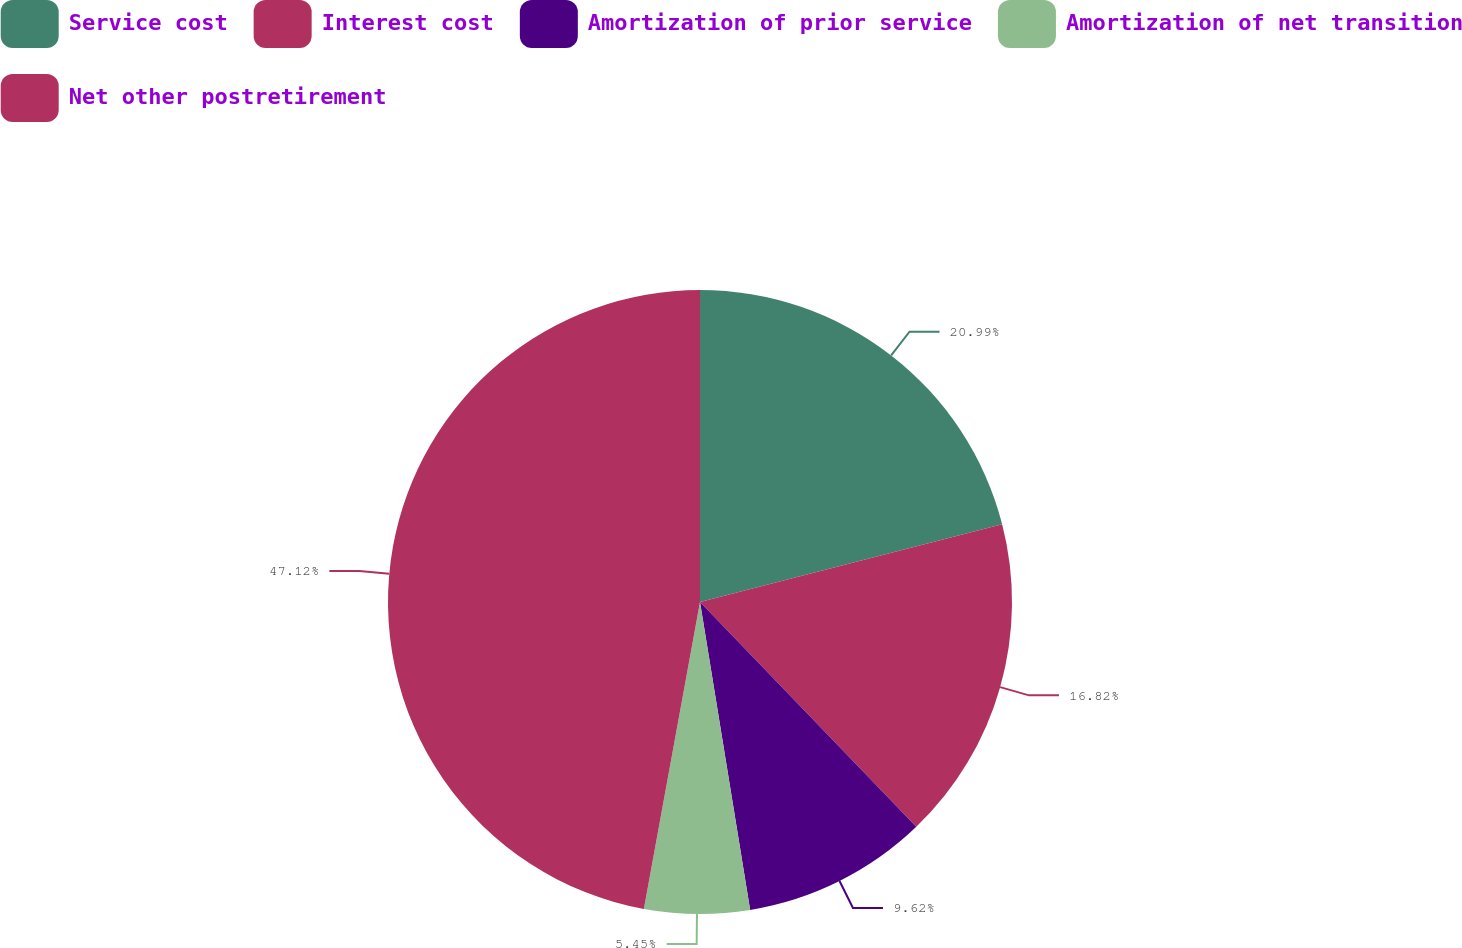Convert chart. <chart><loc_0><loc_0><loc_500><loc_500><pie_chart><fcel>Service cost<fcel>Interest cost<fcel>Amortization of prior service<fcel>Amortization of net transition<fcel>Net other postretirement<nl><fcel>20.99%<fcel>16.82%<fcel>9.62%<fcel>5.45%<fcel>47.12%<nl></chart> 